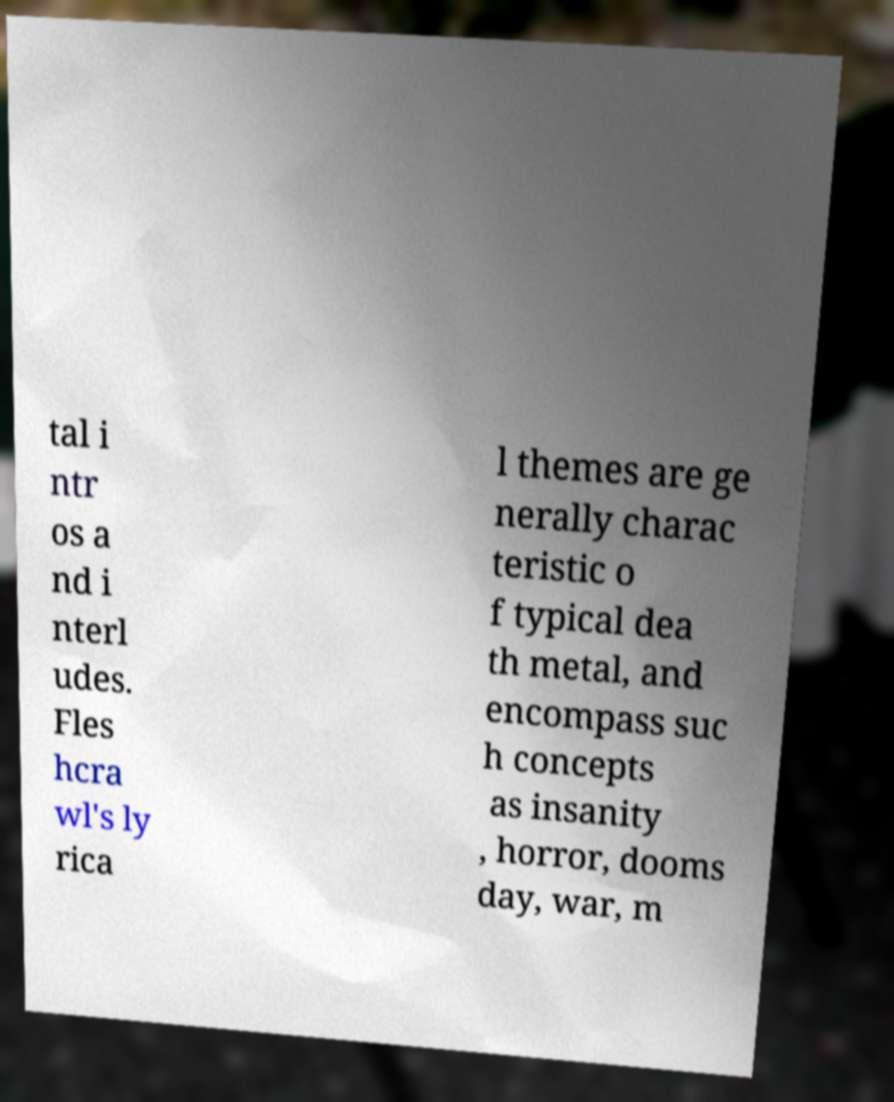I need the written content from this picture converted into text. Can you do that? tal i ntr os a nd i nterl udes. Fles hcra wl's ly rica l themes are ge nerally charac teristic o f typical dea th metal, and encompass suc h concepts as insanity , horror, dooms day, war, m 